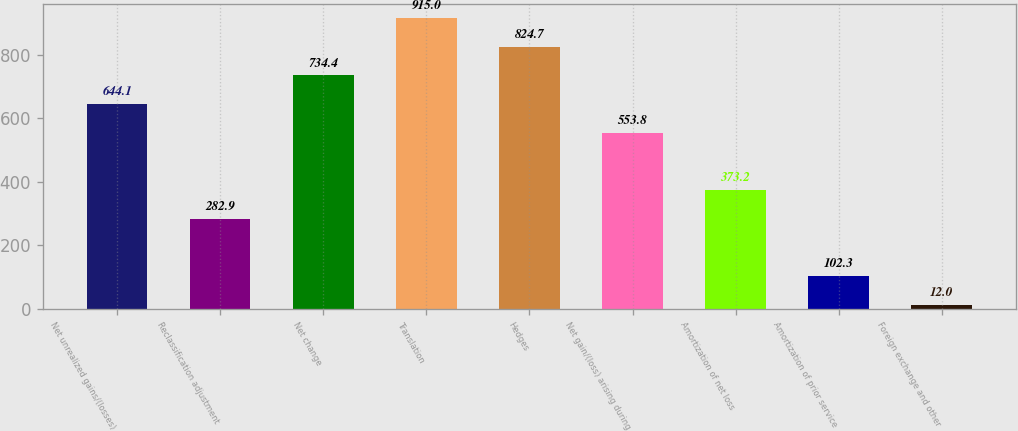Convert chart to OTSL. <chart><loc_0><loc_0><loc_500><loc_500><bar_chart><fcel>Net unrealized gains/(losses)<fcel>Reclassification adjustment<fcel>Net change<fcel>Translation<fcel>Hedges<fcel>Net gain/(loss) arising during<fcel>Amortization of net loss<fcel>Amortization of prior service<fcel>Foreign exchange and other<nl><fcel>644.1<fcel>282.9<fcel>734.4<fcel>915<fcel>824.7<fcel>553.8<fcel>373.2<fcel>102.3<fcel>12<nl></chart> 